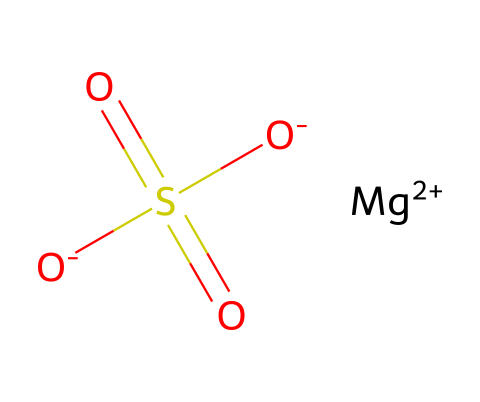What is the name of this chemical? The SMILES notation indicates it's magnesium sulfate, which is commonly known as Epsom salt.
Answer: magnesium sulfate How many oxygen atoms are present? The chemical structure indicates there are four oxygen atoms bonded in the sulfate group.
Answer: four What charge does magnesium carry in this compound? The notation shows magnesium as [Mg+2], which indicates it has a +2 charge.
Answer: +2 How many sulfate groups are present in magnesium sulfate? The presence of the SO4 group indicates there is one sulfate group within the structure.
Answer: one What type of electrolyte is magnesium sulfate characterized as? Magnesium sulfate is considered a salt and in aqueous solutions, it dissociates into magnesium and sulfate ions, making it an electrolyte.
Answer: salt What effect does magnesium sulfate have in an athletic bath? Magnesium sulfate is known for its muscle-relaxing properties, reducing soreness and improving recovery, which helps athletes.
Answer: muscle relaxant What is the oxidation state of sulfur in this compound? In the sulfate ion (SO4), sulfur has an oxidation state of +6, which can be deduced from the bonding structure of the sulfur to four oxygen atoms.
Answer: +6 